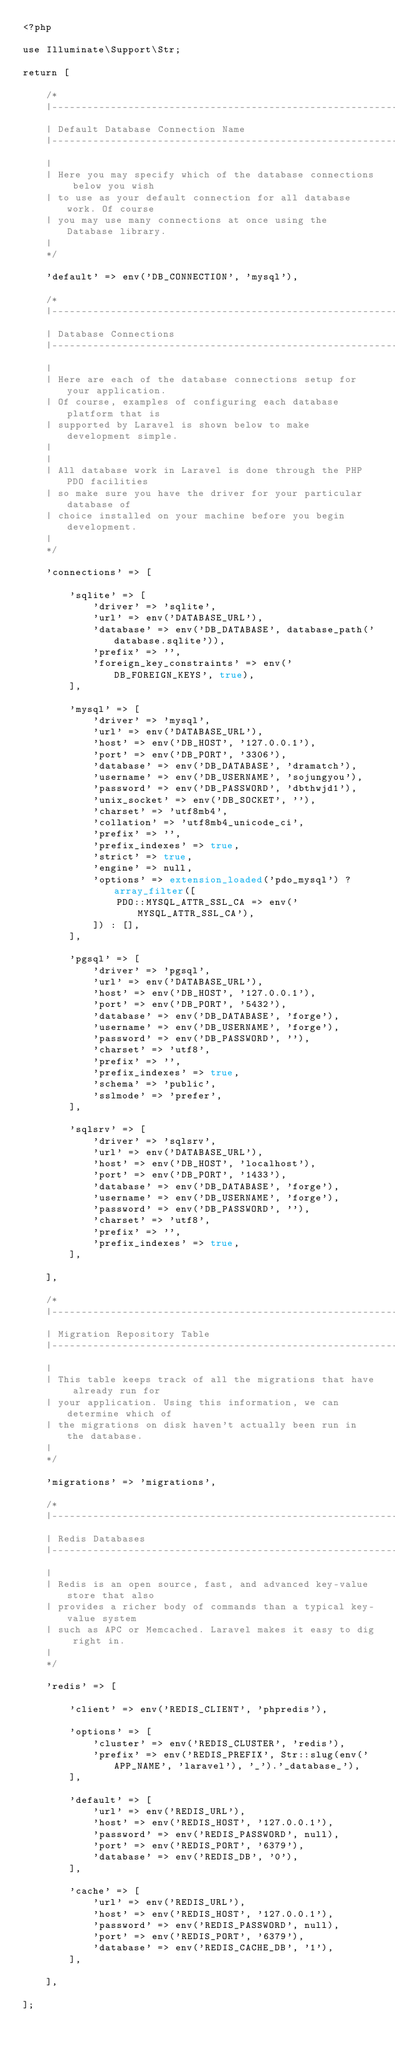<code> <loc_0><loc_0><loc_500><loc_500><_PHP_><?php

use Illuminate\Support\Str;

return [

    /*
    |--------------------------------------------------------------------------
    | Default Database Connection Name
    |--------------------------------------------------------------------------
    |
    | Here you may specify which of the database connections below you wish
    | to use as your default connection for all database work. Of course
    | you may use many connections at once using the Database library.
    |
    */

    'default' => env('DB_CONNECTION', 'mysql'),

    /*
    |--------------------------------------------------------------------------
    | Database Connections
    |--------------------------------------------------------------------------
    |
    | Here are each of the database connections setup for your application.
    | Of course, examples of configuring each database platform that is
    | supported by Laravel is shown below to make development simple.
    |
    |
    | All database work in Laravel is done through the PHP PDO facilities
    | so make sure you have the driver for your particular database of
    | choice installed on your machine before you begin development.
    |
    */

    'connections' => [

        'sqlite' => [
            'driver' => 'sqlite',
            'url' => env('DATABASE_URL'),
            'database' => env('DB_DATABASE', database_path('database.sqlite')),
            'prefix' => '',
            'foreign_key_constraints' => env('DB_FOREIGN_KEYS', true),
        ],

        'mysql' => [
            'driver' => 'mysql',
            'url' => env('DATABASE_URL'),
            'host' => env('DB_HOST', '127.0.0.1'),
            'port' => env('DB_PORT', '3306'),
            'database' => env('DB_DATABASE', 'dramatch'),
            'username' => env('DB_USERNAME', 'sojungyou'),
            'password' => env('DB_PASSWORD', 'dbthwjd1'),
            'unix_socket' => env('DB_SOCKET', ''),
            'charset' => 'utf8mb4',
            'collation' => 'utf8mb4_unicode_ci',
            'prefix' => '',
            'prefix_indexes' => true,
            'strict' => true,
            'engine' => null,
            'options' => extension_loaded('pdo_mysql') ? array_filter([
                PDO::MYSQL_ATTR_SSL_CA => env('MYSQL_ATTR_SSL_CA'),
            ]) : [],
        ],

        'pgsql' => [
            'driver' => 'pgsql',
            'url' => env('DATABASE_URL'),
            'host' => env('DB_HOST', '127.0.0.1'),
            'port' => env('DB_PORT', '5432'),
            'database' => env('DB_DATABASE', 'forge'),
            'username' => env('DB_USERNAME', 'forge'),
            'password' => env('DB_PASSWORD', ''),
            'charset' => 'utf8',
            'prefix' => '',
            'prefix_indexes' => true,
            'schema' => 'public',
            'sslmode' => 'prefer',
        ],

        'sqlsrv' => [
            'driver' => 'sqlsrv',
            'url' => env('DATABASE_URL'),
            'host' => env('DB_HOST', 'localhost'),
            'port' => env('DB_PORT', '1433'),
            'database' => env('DB_DATABASE', 'forge'),
            'username' => env('DB_USERNAME', 'forge'),
            'password' => env('DB_PASSWORD', ''),
            'charset' => 'utf8',
            'prefix' => '',
            'prefix_indexes' => true,
        ],

    ],

    /*
    |--------------------------------------------------------------------------
    | Migration Repository Table
    |--------------------------------------------------------------------------
    |
    | This table keeps track of all the migrations that have already run for
    | your application. Using this information, we can determine which of
    | the migrations on disk haven't actually been run in the database.
    |
    */

    'migrations' => 'migrations',

    /*
    |--------------------------------------------------------------------------
    | Redis Databases
    |--------------------------------------------------------------------------
    |
    | Redis is an open source, fast, and advanced key-value store that also
    | provides a richer body of commands than a typical key-value system
    | such as APC or Memcached. Laravel makes it easy to dig right in.
    |
    */

    'redis' => [

        'client' => env('REDIS_CLIENT', 'phpredis'),

        'options' => [
            'cluster' => env('REDIS_CLUSTER', 'redis'),
            'prefix' => env('REDIS_PREFIX', Str::slug(env('APP_NAME', 'laravel'), '_').'_database_'),
        ],

        'default' => [
            'url' => env('REDIS_URL'),
            'host' => env('REDIS_HOST', '127.0.0.1'),
            'password' => env('REDIS_PASSWORD', null),
            'port' => env('REDIS_PORT', '6379'),
            'database' => env('REDIS_DB', '0'),
        ],

        'cache' => [
            'url' => env('REDIS_URL'),
            'host' => env('REDIS_HOST', '127.0.0.1'),
            'password' => env('REDIS_PASSWORD', null),
            'port' => env('REDIS_PORT', '6379'),
            'database' => env('REDIS_CACHE_DB', '1'),
        ],

    ],

];
</code> 